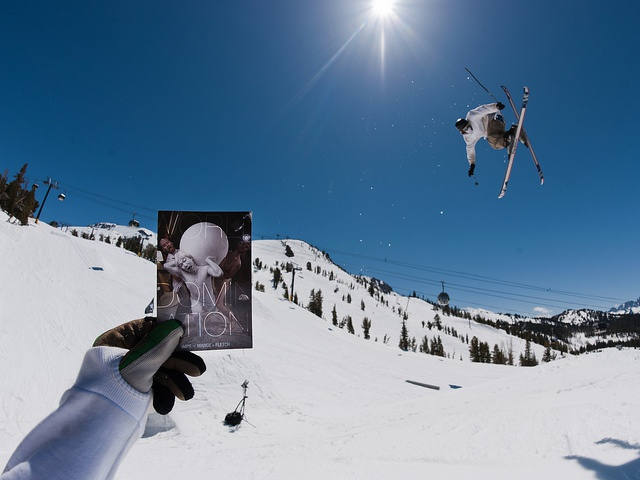Describe the objects in this image and their specific colors. I can see people in darkblue, black, gray, and darkgray tones, people in darkblue, black, darkgray, gray, and blue tones, skis in darkblue, gray, darkgray, and black tones, people in darkblue, black, gray, maroon, and darkgray tones, and people in darkblue, black, darkgray, gray, and lightgray tones in this image. 